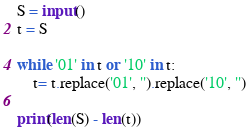<code> <loc_0><loc_0><loc_500><loc_500><_Python_>S = input()
t = S

while '01' in t or '10' in t:
    t= t.replace('01', '').replace('10', '')

print(len(S) - len(t))</code> 